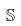<formula> <loc_0><loc_0><loc_500><loc_500>\mathbb { S }</formula> 